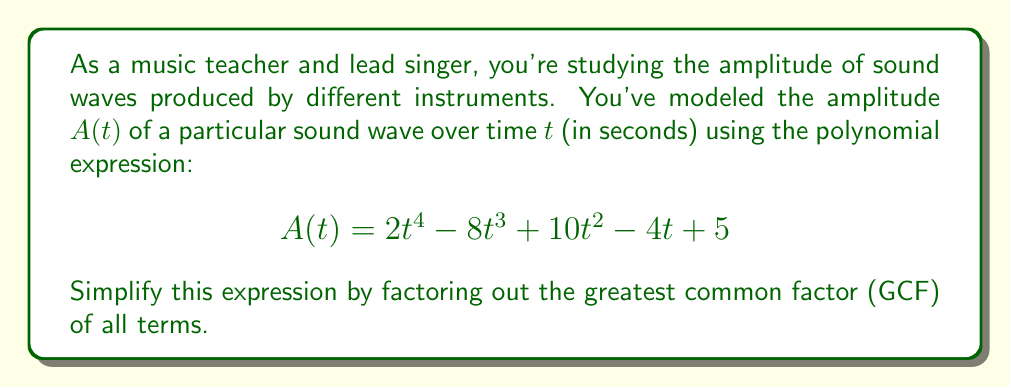Help me with this question. To simplify this polynomial expression by factoring out the greatest common factor (GCF), we'll follow these steps:

1) First, identify the GCF of all terms in the polynomial. To do this, we need to find the largest factor common to all terms:

   $2t^4$: factors are 1, 2, t, $t^2$, $t^3$, $t^4$
   $-8t^3$: factors are 1, 2, 4, 8, t, $t^2$, $t^3$
   $10t^2$: factors are 1, 2, 5, 10, t, $t^2$
   $-4t$: factors are 1, 2, 4, t
   5: factors are 1, 5

   The greatest factor common to all terms is 1.

2) Since the GCF is 1, we can't factor anything out of the entire expression. However, we can group the terms with t:

   $$A(t) = (2t^4 - 8t^3 + 10t^2 - 4t) + 5$$

3) Now, let's factor out the greatest common factor from the grouped terms:

   $2t^4 - 8t^3 + 10t^2 - 4t = 2t(t^3 - 4t^2 + 5t - 2)$

4) Therefore, our simplified expression becomes:

   $$A(t) = 2t(t^3 - 4t^2 + 5t - 2) + 5$$

This is the most simplified form we can achieve by factoring out the GCF.
Answer: $$A(t) = 2t(t^3 - 4t^2 + 5t - 2) + 5$$ 